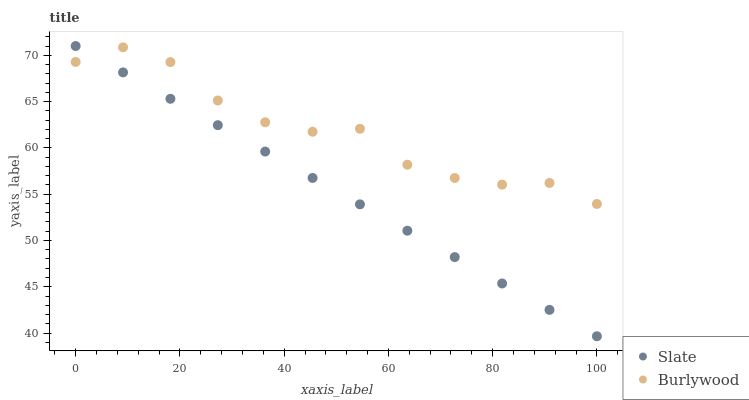Does Slate have the minimum area under the curve?
Answer yes or no. Yes. Does Burlywood have the maximum area under the curve?
Answer yes or no. Yes. Does Slate have the maximum area under the curve?
Answer yes or no. No. Is Slate the smoothest?
Answer yes or no. Yes. Is Burlywood the roughest?
Answer yes or no. Yes. Is Slate the roughest?
Answer yes or no. No. Does Slate have the lowest value?
Answer yes or no. Yes. Does Slate have the highest value?
Answer yes or no. Yes. Does Slate intersect Burlywood?
Answer yes or no. Yes. Is Slate less than Burlywood?
Answer yes or no. No. Is Slate greater than Burlywood?
Answer yes or no. No. 